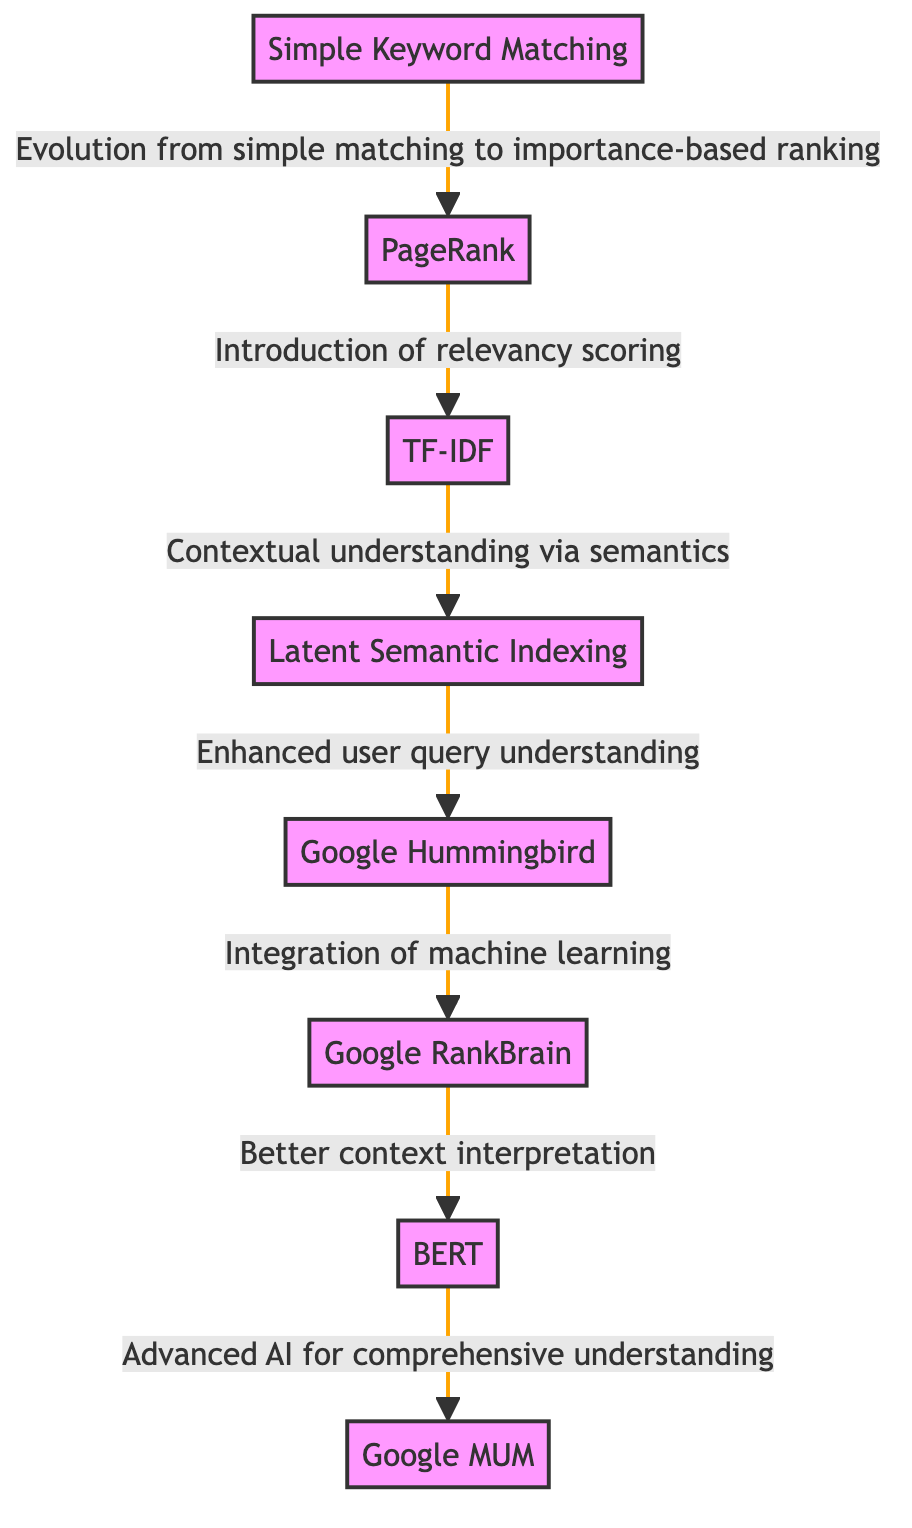What is the first search engine algorithm listed in the diagram? The first node in the diagram is "Simple Keyword Matching," which represents the earliest search engine algorithm before any rankings or more advanced techniques were introduced.
Answer: Simple Keyword Matching How many nodes are there in the diagram? By counting the distinct algorithms represented, there are eight nodes total: Simple Keyword Matching, PageRank, TF-IDF, Latent Semantic Indexing, Hummingbird, RankBrain, BERT, and MUM.
Answer: 8 What does RankBrain improve upon? RankBrain is indicated to improve upon the context interpretation of user queries, which means it takes the basic processes from previous algorithms and optimizes them for understanding context.
Answer: Better context interpretation Which algorithm directly follows Latent Semantic Indexing? The diagram shows that Hummingbird follows Latent Semantic Indexing, meaning it builds properly upon the advancements made by the previous technology in understanding user queries.
Answer: Hummingbird What is the relationship between Hummingbird and RankBrain described as? The relationship is described explicitly as "Integration of machine learning," which indicates how Hummingbird laid the groundwork for RankBrain to enhance user query understanding using machine learning techniques.
Answer: Integration of machine learning What is the last algorithm mentioned in the evolution of search engine algorithms? The final algorithm listed in the progression of search engine technology in the diagram is Google's MUM, representing the latest advancements in this series of algorithms.
Answer: Google MUM How does BERT enhance search engines according to the flow? BERT enhances search engine capabilities by applying advanced AI for comprehensive understanding, illustrating a significant leap from RankBrain's context interpretation.
Answer: Advanced AI for comprehensive understanding Which algorithm introduces relevancy scoring? The diagram indicates that PageRank is responsible for introducing relevancy scoring to the search engine evolution, thereby marking a shift from simple keyword matching to more sophisticated ranking methodologies.
Answer: PageRank 